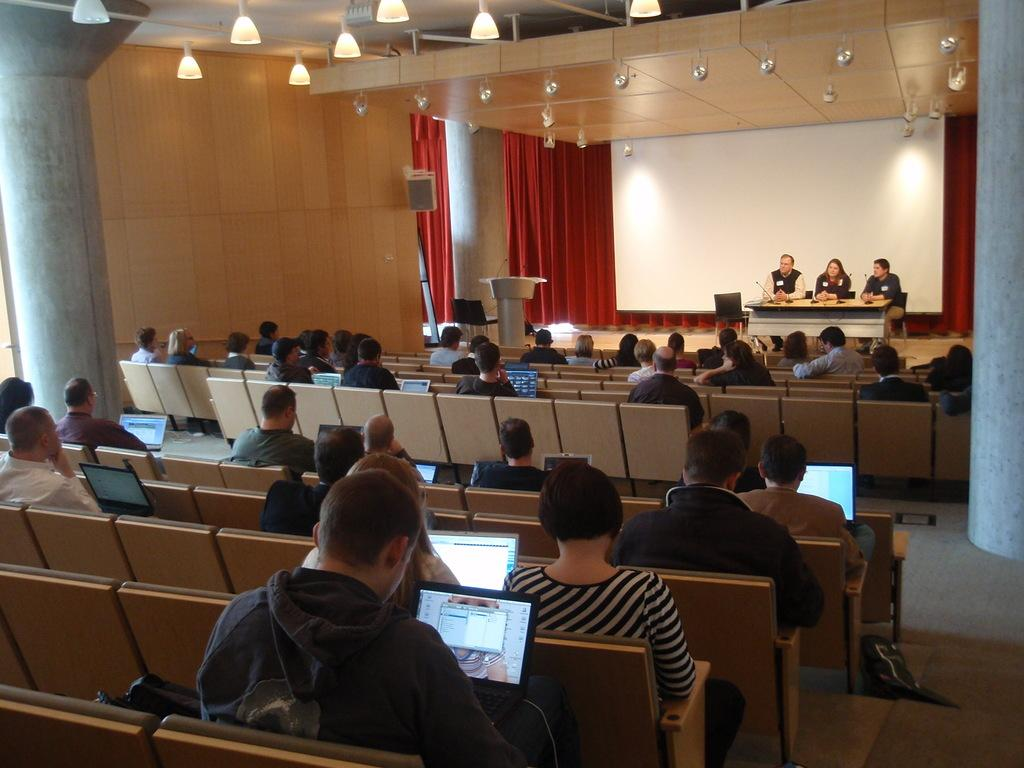What type of structure can be seen in the image? There is a wall in the image. What type of window treatment is present in the image? There are curtains in the image. What type of lighting is visible in the image? There are lights in the image. What are the people in the image doing? There are people sitting on chairs in the image. What type of electronic devices are present in the image? There are laptops in the image. What type of equipment is used for amplifying sound in the image? There are microphones (mics) in the image. What type of furniture is present in the image? There is a table in the image. How many cushions are visible on the chairs in the image? There is no mention of cushions on the chairs in the image. What type of society is depicted in the image? The image does not depict a society; it shows people sitting on chairs with laptops and microphones. Is there a girl present in the image? The provided facts do not mention the presence of a girl in the image. 